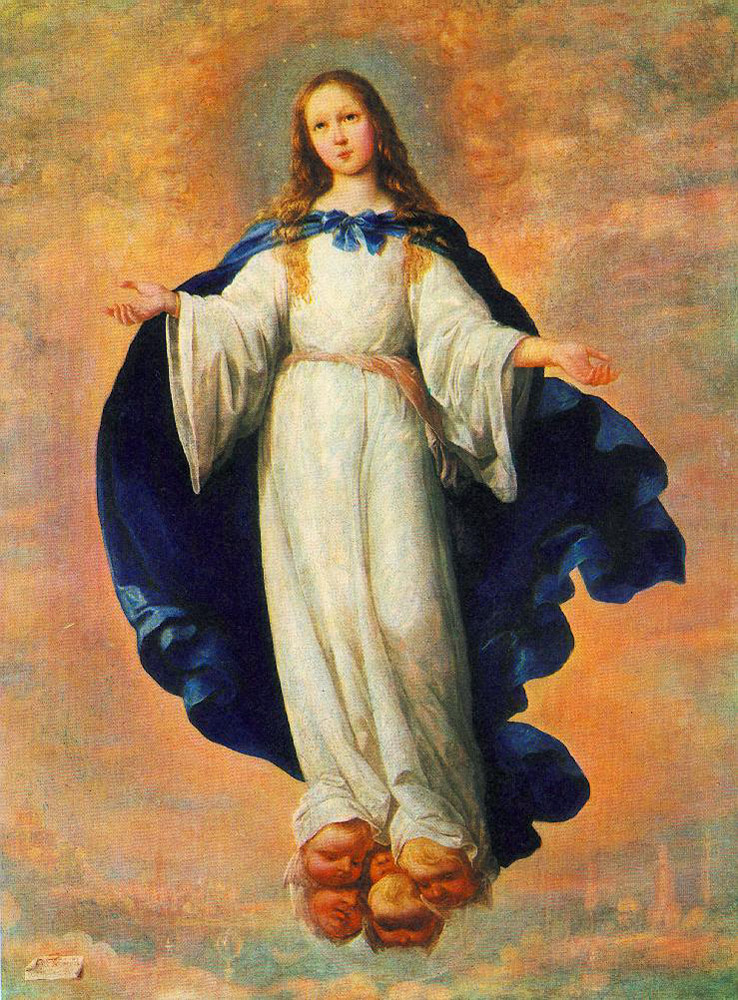Can you tell me more about the symbolism of the girl’s pose in this artwork? Certainly! The girl’s open-armed pose is reminiscent of traditional depictions of spiritual benevolence or openness. It may symbolize protection or an offering of peace, often associated with celestial beings in religious art. Her upward gaze and elevated position could also suggest a connection to the divine, overseeing the earthly realm. 